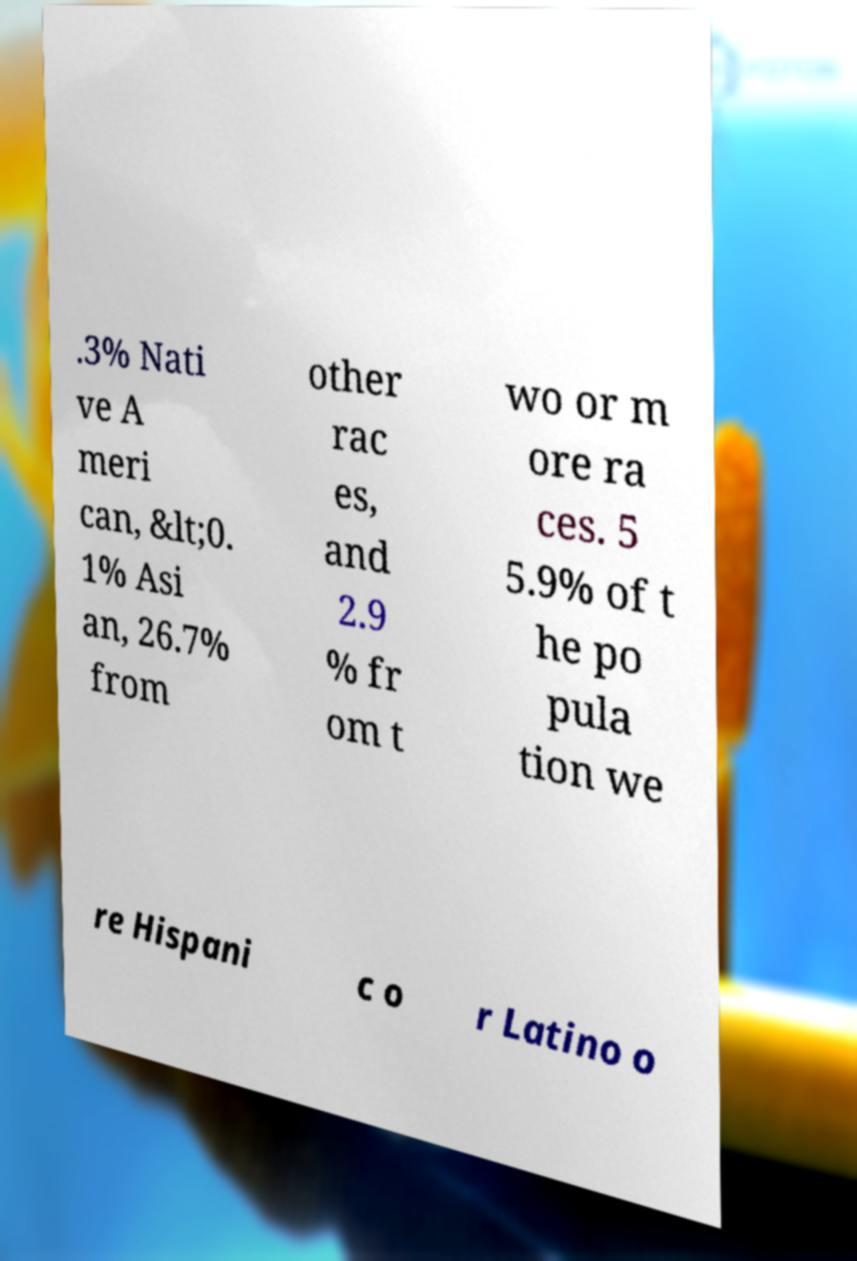Please read and relay the text visible in this image. What does it say? .3% Nati ve A meri can, &lt;0. 1% Asi an, 26.7% from other rac es, and 2.9 % fr om t wo or m ore ra ces. 5 5.9% of t he po pula tion we re Hispani c o r Latino o 